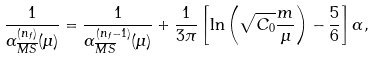<formula> <loc_0><loc_0><loc_500><loc_500>\frac { 1 } { \alpha ^ { ( n _ { f } ) } _ { \overline { M S } } ( \mu ) } = \frac { 1 } { \alpha ^ { ( n _ { f } - 1 ) } _ { \overline { M S } } ( \mu ) } + \frac { 1 } { 3 \pi } \left [ \ln \left ( \sqrt { C _ { 0 } } \frac { m } { \mu } \right ) - \frac { 5 } { 6 } \right ] \alpha ,</formula> 